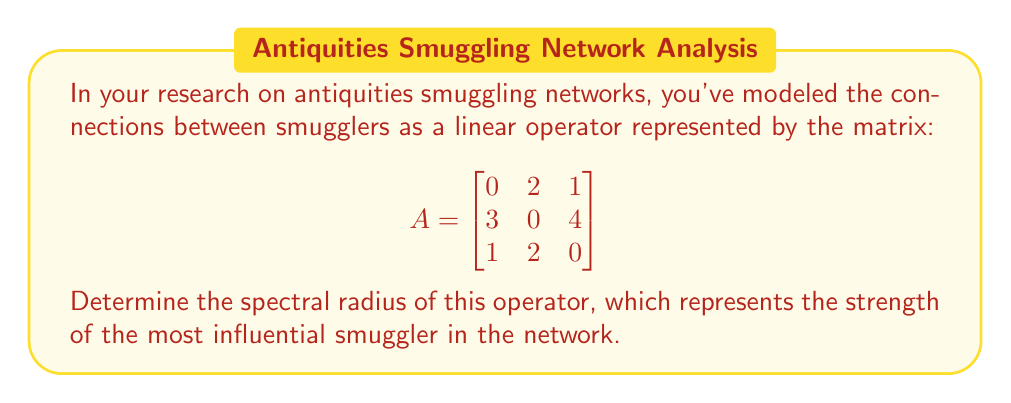Solve this math problem. To find the spectral radius of the linear operator, we need to follow these steps:

1) First, calculate the characteristic polynomial of matrix A:
   $$\det(A - \lambda I) = \begin{vmatrix}
   -\lambda & 2 & 1 \\
   3 & -\lambda & 4 \\
   1 & 2 & -\lambda
   \end{vmatrix}$$

2) Expand the determinant:
   $$-\lambda^3 + 2\lambda - 6 - 8 - 3 + 4\lambda = -\lambda^3 + 6\lambda - 17 = 0$$

3) This cubic equation is difficult to solve analytically. We can use the fact that the spectral radius is less than or equal to any matrix norm. The infinity norm of A is:
   $$\|A\|_{\infty} = \max_{1 \leq i \leq n} \sum_{j=1}^n |a_{ij}| = \max(3, 7, 3) = 7$$

4) Therefore, all eigenvalues $\lambda$ satisfy $|\lambda| \leq 7$.

5) We can use numerical methods to find the roots of the characteristic polynomial. The three roots are approximately:
   $\lambda_1 \approx 5.0489$
   $\lambda_2 \approx -2.0244 + 1.7321i$
   $\lambda_3 \approx -2.0244 - 1.7321i$

6) The spectral radius is the maximum absolute value of these eigenvalues:
   $$\rho(A) = \max(|\lambda_1|, |\lambda_2|, |\lambda_3|) = |\lambda_1| \approx 5.0489$$
Answer: $5.0489$ 